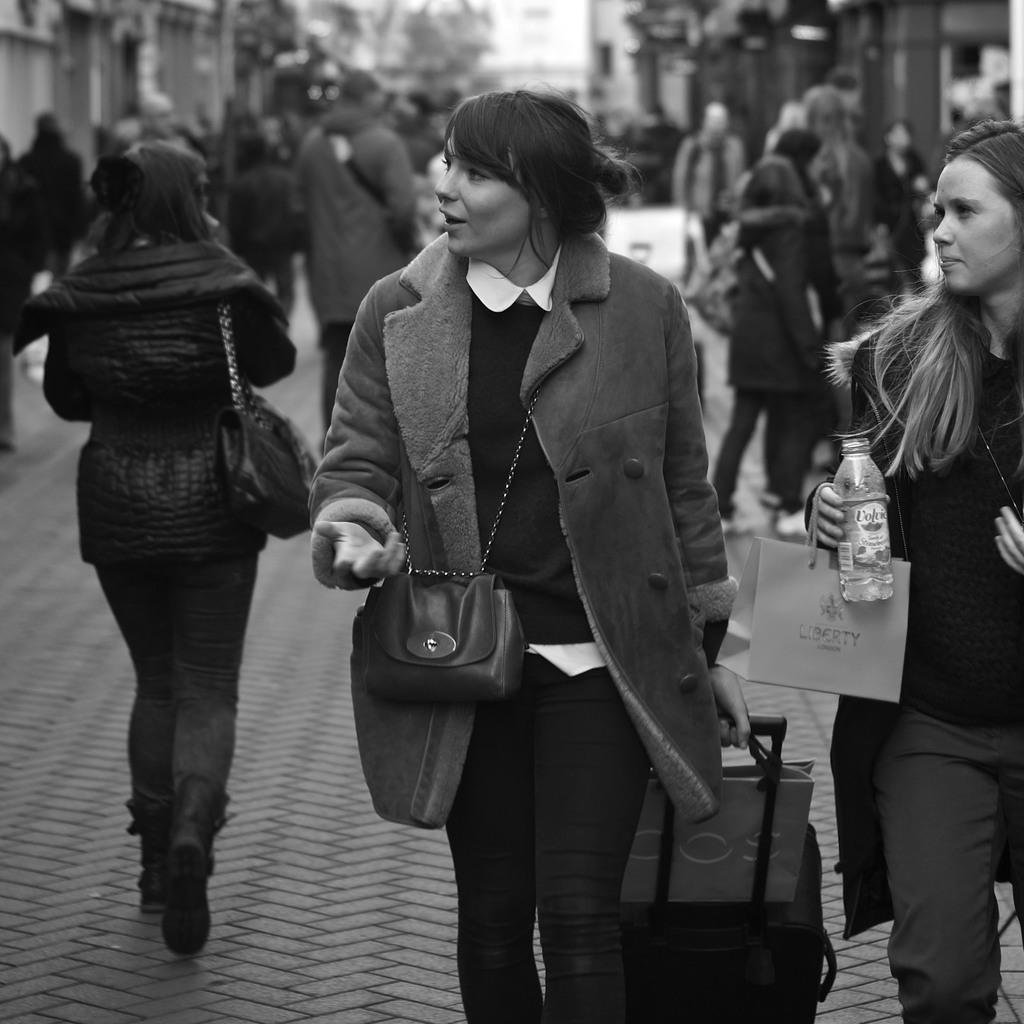What is the lady in the image doing? The lady in the image is walking. What is the lady carrying with her? The lady is wearing a handbag and pulling a trolley bag. What else is the lady holding in the image? The lady is holding a water bottle. Are there any other people in the image? Yes, there is a group of people standing in the image. How many dimes can be seen on the ground in the image? There are no dimes visible on the ground in the image. What type of twig is the lady holding in the image? The lady is not holding a twig in the image; she is holding a water bottle. 